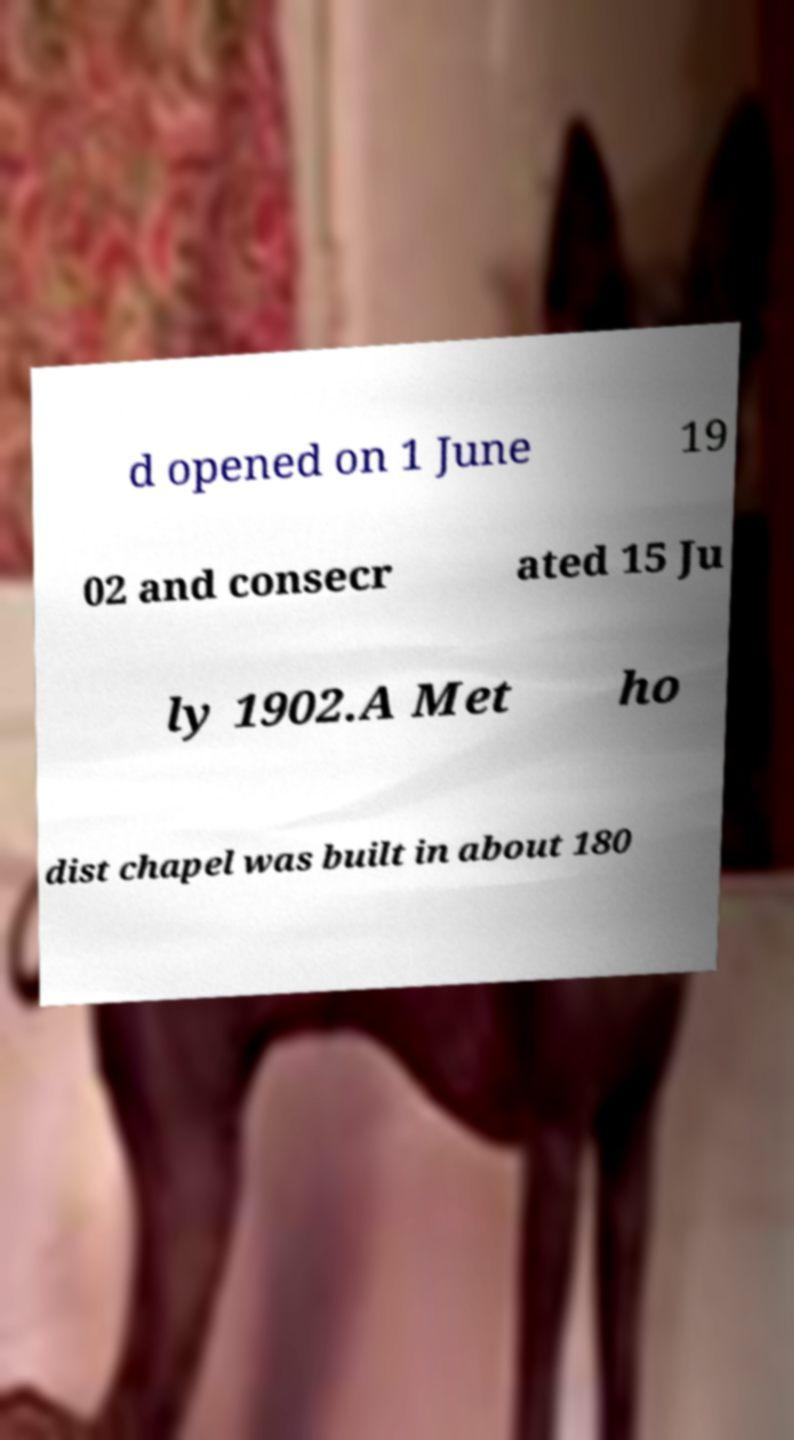Could you extract and type out the text from this image? d opened on 1 June 19 02 and consecr ated 15 Ju ly 1902.A Met ho dist chapel was built in about 180 